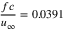Convert formula to latex. <formula><loc_0><loc_0><loc_500><loc_500>\frac { f c } { u _ { \infty } } = 0 . 0 3 9 1</formula> 